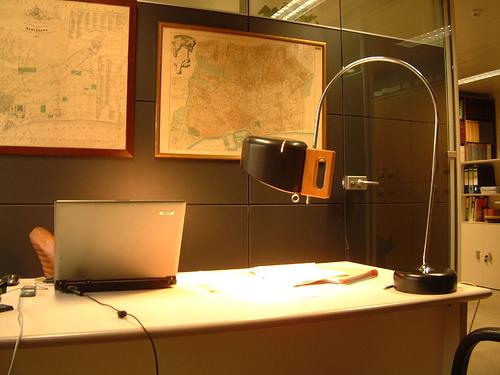How many humans are in the picture?
Be succinct. 0. What are the picture frames made of?
Write a very short answer. Wood. What is on the desk?
Be succinct. Laptop. 